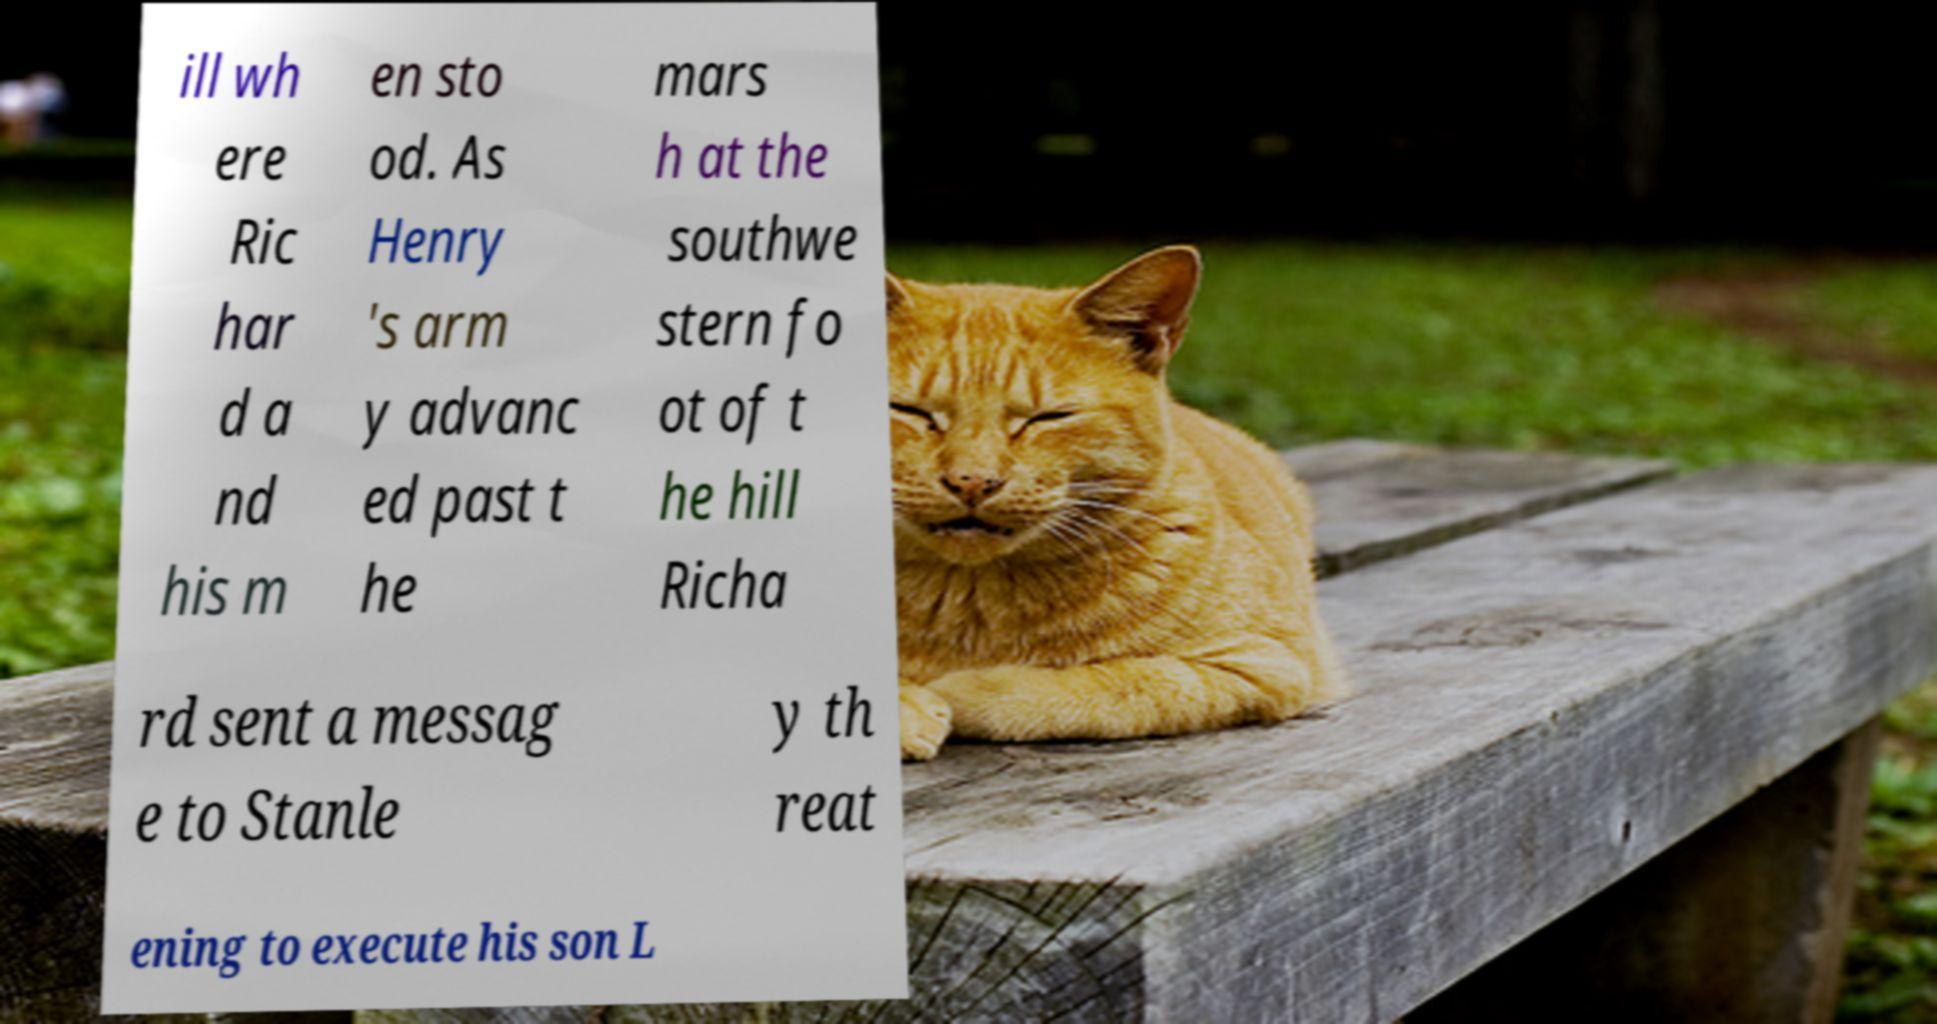Could you extract and type out the text from this image? ill wh ere Ric har d a nd his m en sto od. As Henry 's arm y advanc ed past t he mars h at the southwe stern fo ot of t he hill Richa rd sent a messag e to Stanle y th reat ening to execute his son L 